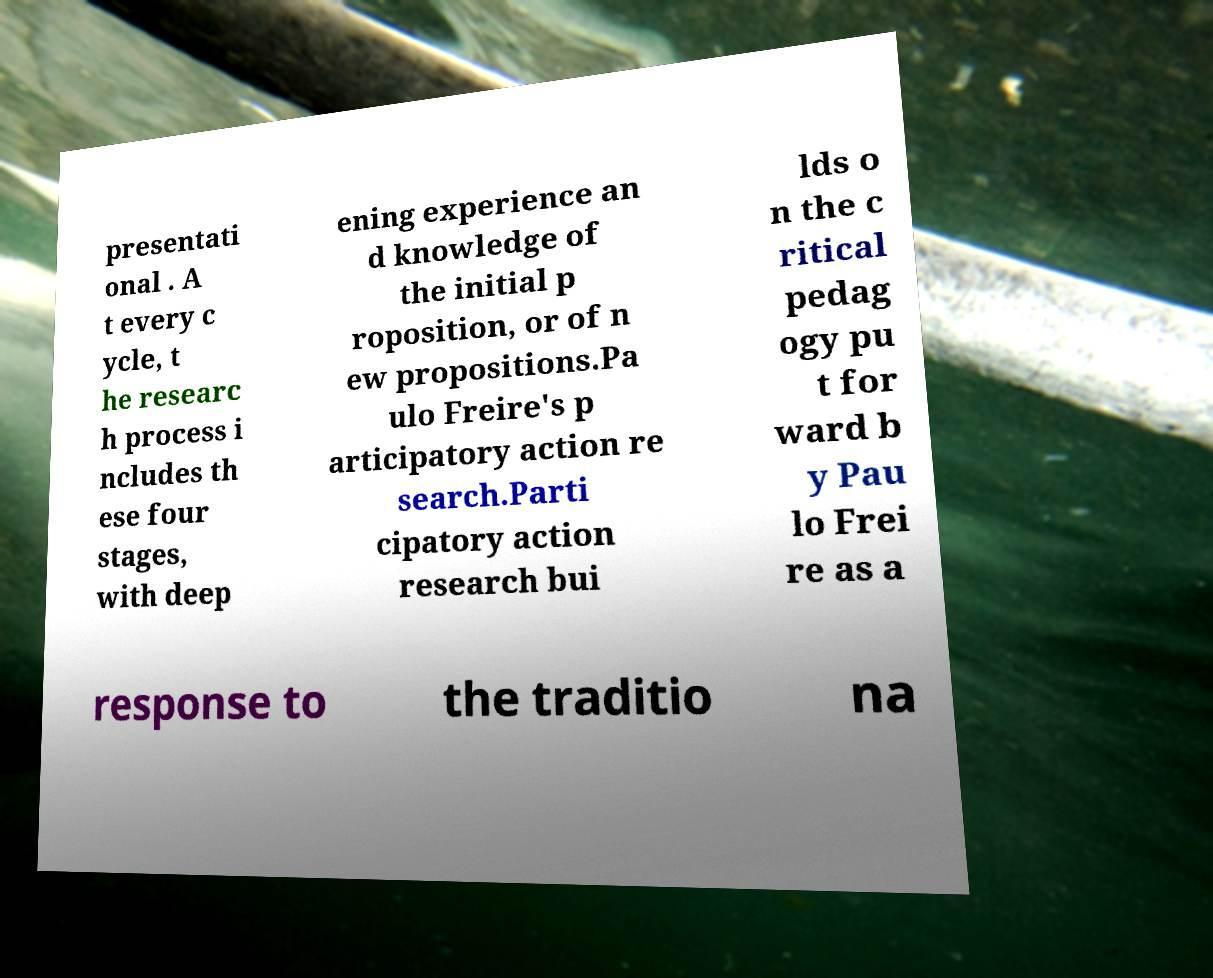There's text embedded in this image that I need extracted. Can you transcribe it verbatim? presentati onal . A t every c ycle, t he researc h process i ncludes th ese four stages, with deep ening experience an d knowledge of the initial p roposition, or of n ew propositions.Pa ulo Freire's p articipatory action re search.Parti cipatory action research bui lds o n the c ritical pedag ogy pu t for ward b y Pau lo Frei re as a response to the traditio na 